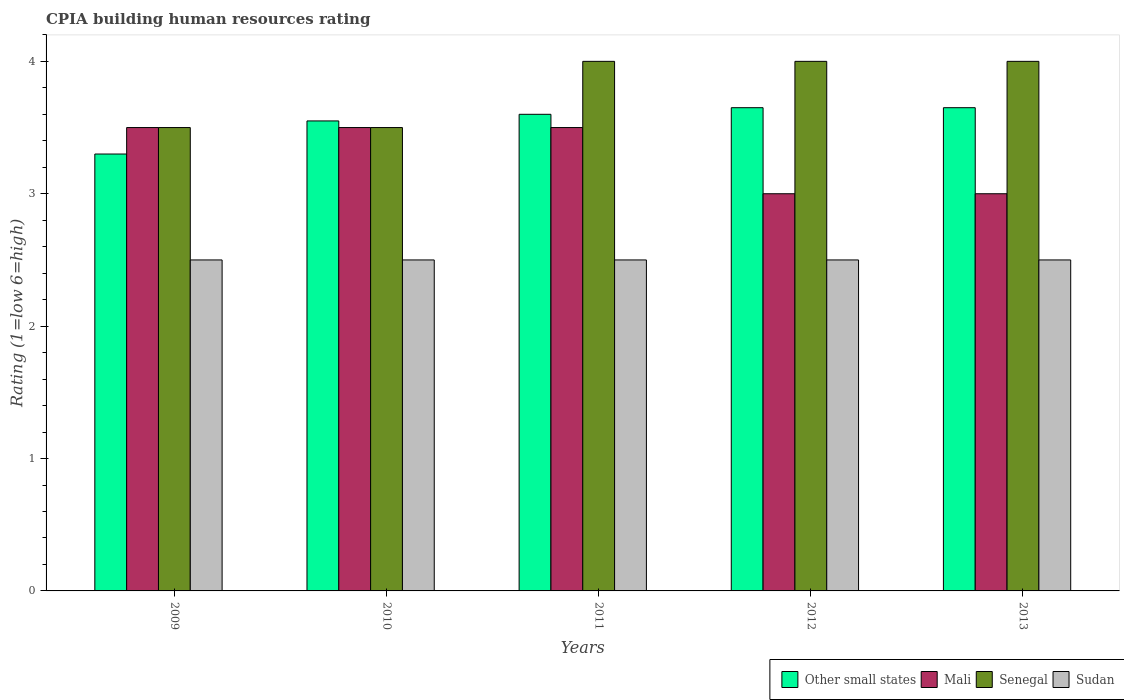Are the number of bars on each tick of the X-axis equal?
Your answer should be very brief. Yes. How many bars are there on the 3rd tick from the right?
Keep it short and to the point. 4. What is the label of the 1st group of bars from the left?
Keep it short and to the point. 2009. In how many cases, is the number of bars for a given year not equal to the number of legend labels?
Provide a succinct answer. 0. Across all years, what is the minimum CPIA rating in Senegal?
Offer a very short reply. 3.5. In which year was the CPIA rating in Sudan maximum?
Provide a short and direct response. 2009. What is the total CPIA rating in Other small states in the graph?
Your answer should be very brief. 17.75. What is the difference between the CPIA rating in Other small states in 2010 and that in 2013?
Ensure brevity in your answer.  -0.1. What is the difference between the CPIA rating in Senegal in 2012 and the CPIA rating in Other small states in 2013?
Ensure brevity in your answer.  0.35. In how many years, is the CPIA rating in Senegal greater than 1.8?
Provide a short and direct response. 5. What is the ratio of the CPIA rating in Other small states in 2011 to that in 2013?
Provide a short and direct response. 0.99. Is the difference between the CPIA rating in Sudan in 2009 and 2013 greater than the difference between the CPIA rating in Mali in 2009 and 2013?
Your answer should be very brief. No. In how many years, is the CPIA rating in Senegal greater than the average CPIA rating in Senegal taken over all years?
Keep it short and to the point. 3. Is it the case that in every year, the sum of the CPIA rating in Sudan and CPIA rating in Other small states is greater than the sum of CPIA rating in Mali and CPIA rating in Senegal?
Keep it short and to the point. No. What does the 1st bar from the left in 2013 represents?
Make the answer very short. Other small states. What does the 4th bar from the right in 2009 represents?
Provide a succinct answer. Other small states. How many bars are there?
Your response must be concise. 20. How many years are there in the graph?
Provide a short and direct response. 5. Are the values on the major ticks of Y-axis written in scientific E-notation?
Give a very brief answer. No. Does the graph contain any zero values?
Make the answer very short. No. Does the graph contain grids?
Keep it short and to the point. No. Where does the legend appear in the graph?
Your response must be concise. Bottom right. What is the title of the graph?
Keep it short and to the point. CPIA building human resources rating. Does "Switzerland" appear as one of the legend labels in the graph?
Keep it short and to the point. No. What is the label or title of the X-axis?
Make the answer very short. Years. What is the Rating (1=low 6=high) of Other small states in 2009?
Offer a very short reply. 3.3. What is the Rating (1=low 6=high) of Mali in 2009?
Offer a very short reply. 3.5. What is the Rating (1=low 6=high) in Other small states in 2010?
Your answer should be very brief. 3.55. What is the Rating (1=low 6=high) of Mali in 2010?
Make the answer very short. 3.5. What is the Rating (1=low 6=high) in Senegal in 2010?
Give a very brief answer. 3.5. What is the Rating (1=low 6=high) of Senegal in 2011?
Provide a succinct answer. 4. What is the Rating (1=low 6=high) in Sudan in 2011?
Your response must be concise. 2.5. What is the Rating (1=low 6=high) in Other small states in 2012?
Your response must be concise. 3.65. What is the Rating (1=low 6=high) in Other small states in 2013?
Make the answer very short. 3.65. Across all years, what is the maximum Rating (1=low 6=high) in Other small states?
Offer a very short reply. 3.65. Across all years, what is the maximum Rating (1=low 6=high) in Mali?
Offer a very short reply. 3.5. Across all years, what is the maximum Rating (1=low 6=high) in Senegal?
Offer a terse response. 4. Across all years, what is the maximum Rating (1=low 6=high) of Sudan?
Make the answer very short. 2.5. Across all years, what is the minimum Rating (1=low 6=high) of Sudan?
Provide a short and direct response. 2.5. What is the total Rating (1=low 6=high) of Other small states in the graph?
Your answer should be compact. 17.75. What is the total Rating (1=low 6=high) of Mali in the graph?
Ensure brevity in your answer.  16.5. What is the total Rating (1=low 6=high) of Senegal in the graph?
Make the answer very short. 19. What is the total Rating (1=low 6=high) of Sudan in the graph?
Your response must be concise. 12.5. What is the difference between the Rating (1=low 6=high) in Other small states in 2009 and that in 2010?
Your answer should be compact. -0.25. What is the difference between the Rating (1=low 6=high) in Other small states in 2009 and that in 2011?
Make the answer very short. -0.3. What is the difference between the Rating (1=low 6=high) in Other small states in 2009 and that in 2012?
Make the answer very short. -0.35. What is the difference between the Rating (1=low 6=high) of Mali in 2009 and that in 2012?
Provide a short and direct response. 0.5. What is the difference between the Rating (1=low 6=high) of Sudan in 2009 and that in 2012?
Give a very brief answer. 0. What is the difference between the Rating (1=low 6=high) of Other small states in 2009 and that in 2013?
Offer a very short reply. -0.35. What is the difference between the Rating (1=low 6=high) of Sudan in 2009 and that in 2013?
Your answer should be compact. 0. What is the difference between the Rating (1=low 6=high) in Other small states in 2010 and that in 2011?
Give a very brief answer. -0.05. What is the difference between the Rating (1=low 6=high) in Senegal in 2010 and that in 2011?
Your answer should be compact. -0.5. What is the difference between the Rating (1=low 6=high) of Other small states in 2010 and that in 2013?
Offer a terse response. -0.1. What is the difference between the Rating (1=low 6=high) in Mali in 2010 and that in 2013?
Keep it short and to the point. 0.5. What is the difference between the Rating (1=low 6=high) in Other small states in 2011 and that in 2012?
Provide a short and direct response. -0.05. What is the difference between the Rating (1=low 6=high) in Mali in 2011 and that in 2013?
Ensure brevity in your answer.  0.5. What is the difference between the Rating (1=low 6=high) of Senegal in 2011 and that in 2013?
Make the answer very short. 0. What is the difference between the Rating (1=low 6=high) of Other small states in 2012 and that in 2013?
Provide a succinct answer. 0. What is the difference between the Rating (1=low 6=high) of Mali in 2012 and that in 2013?
Offer a very short reply. 0. What is the difference between the Rating (1=low 6=high) in Senegal in 2012 and that in 2013?
Keep it short and to the point. 0. What is the difference between the Rating (1=low 6=high) in Other small states in 2009 and the Rating (1=low 6=high) in Senegal in 2010?
Keep it short and to the point. -0.2. What is the difference between the Rating (1=low 6=high) of Mali in 2009 and the Rating (1=low 6=high) of Senegal in 2010?
Offer a very short reply. 0. What is the difference between the Rating (1=low 6=high) in Senegal in 2009 and the Rating (1=low 6=high) in Sudan in 2010?
Your answer should be very brief. 1. What is the difference between the Rating (1=low 6=high) in Other small states in 2009 and the Rating (1=low 6=high) in Mali in 2011?
Offer a very short reply. -0.2. What is the difference between the Rating (1=low 6=high) of Other small states in 2009 and the Rating (1=low 6=high) of Sudan in 2011?
Make the answer very short. 0.8. What is the difference between the Rating (1=low 6=high) of Mali in 2009 and the Rating (1=low 6=high) of Senegal in 2011?
Your answer should be very brief. -0.5. What is the difference between the Rating (1=low 6=high) of Other small states in 2009 and the Rating (1=low 6=high) of Senegal in 2012?
Provide a succinct answer. -0.7. What is the difference between the Rating (1=low 6=high) in Mali in 2009 and the Rating (1=low 6=high) in Senegal in 2012?
Provide a short and direct response. -0.5. What is the difference between the Rating (1=low 6=high) in Senegal in 2009 and the Rating (1=low 6=high) in Sudan in 2012?
Provide a succinct answer. 1. What is the difference between the Rating (1=low 6=high) of Mali in 2009 and the Rating (1=low 6=high) of Senegal in 2013?
Give a very brief answer. -0.5. What is the difference between the Rating (1=low 6=high) of Other small states in 2010 and the Rating (1=low 6=high) of Senegal in 2011?
Ensure brevity in your answer.  -0.45. What is the difference between the Rating (1=low 6=high) in Other small states in 2010 and the Rating (1=low 6=high) in Sudan in 2011?
Make the answer very short. 1.05. What is the difference between the Rating (1=low 6=high) of Mali in 2010 and the Rating (1=low 6=high) of Senegal in 2011?
Offer a terse response. -0.5. What is the difference between the Rating (1=low 6=high) in Mali in 2010 and the Rating (1=low 6=high) in Sudan in 2011?
Ensure brevity in your answer.  1. What is the difference between the Rating (1=low 6=high) in Senegal in 2010 and the Rating (1=low 6=high) in Sudan in 2011?
Offer a very short reply. 1. What is the difference between the Rating (1=low 6=high) of Other small states in 2010 and the Rating (1=low 6=high) of Mali in 2012?
Keep it short and to the point. 0.55. What is the difference between the Rating (1=low 6=high) of Other small states in 2010 and the Rating (1=low 6=high) of Senegal in 2012?
Ensure brevity in your answer.  -0.45. What is the difference between the Rating (1=low 6=high) in Mali in 2010 and the Rating (1=low 6=high) in Senegal in 2012?
Ensure brevity in your answer.  -0.5. What is the difference between the Rating (1=low 6=high) of Other small states in 2010 and the Rating (1=low 6=high) of Mali in 2013?
Your response must be concise. 0.55. What is the difference between the Rating (1=low 6=high) in Other small states in 2010 and the Rating (1=low 6=high) in Senegal in 2013?
Offer a terse response. -0.45. What is the difference between the Rating (1=low 6=high) in Other small states in 2010 and the Rating (1=low 6=high) in Sudan in 2013?
Provide a short and direct response. 1.05. What is the difference between the Rating (1=low 6=high) in Mali in 2010 and the Rating (1=low 6=high) in Senegal in 2013?
Give a very brief answer. -0.5. What is the difference between the Rating (1=low 6=high) in Mali in 2010 and the Rating (1=low 6=high) in Sudan in 2013?
Offer a very short reply. 1. What is the difference between the Rating (1=low 6=high) in Other small states in 2011 and the Rating (1=low 6=high) in Mali in 2012?
Give a very brief answer. 0.6. What is the difference between the Rating (1=low 6=high) in Other small states in 2011 and the Rating (1=low 6=high) in Senegal in 2012?
Give a very brief answer. -0.4. What is the difference between the Rating (1=low 6=high) in Other small states in 2011 and the Rating (1=low 6=high) in Sudan in 2012?
Ensure brevity in your answer.  1.1. What is the difference between the Rating (1=low 6=high) in Mali in 2011 and the Rating (1=low 6=high) in Sudan in 2012?
Offer a terse response. 1. What is the difference between the Rating (1=low 6=high) of Senegal in 2011 and the Rating (1=low 6=high) of Sudan in 2012?
Offer a very short reply. 1.5. What is the difference between the Rating (1=low 6=high) of Mali in 2011 and the Rating (1=low 6=high) of Senegal in 2013?
Give a very brief answer. -0.5. What is the difference between the Rating (1=low 6=high) in Mali in 2011 and the Rating (1=low 6=high) in Sudan in 2013?
Provide a succinct answer. 1. What is the difference between the Rating (1=low 6=high) of Senegal in 2011 and the Rating (1=low 6=high) of Sudan in 2013?
Offer a very short reply. 1.5. What is the difference between the Rating (1=low 6=high) in Other small states in 2012 and the Rating (1=low 6=high) in Mali in 2013?
Give a very brief answer. 0.65. What is the difference between the Rating (1=low 6=high) in Other small states in 2012 and the Rating (1=low 6=high) in Senegal in 2013?
Give a very brief answer. -0.35. What is the difference between the Rating (1=low 6=high) of Other small states in 2012 and the Rating (1=low 6=high) of Sudan in 2013?
Make the answer very short. 1.15. What is the difference between the Rating (1=low 6=high) in Mali in 2012 and the Rating (1=low 6=high) in Senegal in 2013?
Make the answer very short. -1. What is the difference between the Rating (1=low 6=high) of Mali in 2012 and the Rating (1=low 6=high) of Sudan in 2013?
Provide a succinct answer. 0.5. What is the average Rating (1=low 6=high) in Other small states per year?
Offer a terse response. 3.55. What is the average Rating (1=low 6=high) of Mali per year?
Your answer should be very brief. 3.3. In the year 2009, what is the difference between the Rating (1=low 6=high) in Other small states and Rating (1=low 6=high) in Sudan?
Your answer should be very brief. 0.8. In the year 2010, what is the difference between the Rating (1=low 6=high) of Other small states and Rating (1=low 6=high) of Sudan?
Your answer should be very brief. 1.05. In the year 2011, what is the difference between the Rating (1=low 6=high) of Other small states and Rating (1=low 6=high) of Senegal?
Make the answer very short. -0.4. In the year 2011, what is the difference between the Rating (1=low 6=high) of Mali and Rating (1=low 6=high) of Sudan?
Ensure brevity in your answer.  1. In the year 2011, what is the difference between the Rating (1=low 6=high) of Senegal and Rating (1=low 6=high) of Sudan?
Your answer should be very brief. 1.5. In the year 2012, what is the difference between the Rating (1=low 6=high) in Other small states and Rating (1=low 6=high) in Mali?
Provide a succinct answer. 0.65. In the year 2012, what is the difference between the Rating (1=low 6=high) of Other small states and Rating (1=low 6=high) of Senegal?
Your response must be concise. -0.35. In the year 2012, what is the difference between the Rating (1=low 6=high) of Other small states and Rating (1=low 6=high) of Sudan?
Provide a short and direct response. 1.15. In the year 2012, what is the difference between the Rating (1=low 6=high) in Mali and Rating (1=low 6=high) in Senegal?
Keep it short and to the point. -1. In the year 2012, what is the difference between the Rating (1=low 6=high) of Mali and Rating (1=low 6=high) of Sudan?
Provide a short and direct response. 0.5. In the year 2013, what is the difference between the Rating (1=low 6=high) of Other small states and Rating (1=low 6=high) of Mali?
Ensure brevity in your answer.  0.65. In the year 2013, what is the difference between the Rating (1=low 6=high) in Other small states and Rating (1=low 6=high) in Senegal?
Your response must be concise. -0.35. In the year 2013, what is the difference between the Rating (1=low 6=high) of Other small states and Rating (1=low 6=high) of Sudan?
Offer a very short reply. 1.15. In the year 2013, what is the difference between the Rating (1=low 6=high) in Mali and Rating (1=low 6=high) in Sudan?
Your response must be concise. 0.5. What is the ratio of the Rating (1=low 6=high) in Other small states in 2009 to that in 2010?
Offer a very short reply. 0.93. What is the ratio of the Rating (1=low 6=high) in Senegal in 2009 to that in 2010?
Provide a succinct answer. 1. What is the ratio of the Rating (1=low 6=high) of Sudan in 2009 to that in 2010?
Ensure brevity in your answer.  1. What is the ratio of the Rating (1=low 6=high) of Mali in 2009 to that in 2011?
Your response must be concise. 1. What is the ratio of the Rating (1=low 6=high) of Senegal in 2009 to that in 2011?
Give a very brief answer. 0.88. What is the ratio of the Rating (1=low 6=high) in Sudan in 2009 to that in 2011?
Offer a terse response. 1. What is the ratio of the Rating (1=low 6=high) of Other small states in 2009 to that in 2012?
Your response must be concise. 0.9. What is the ratio of the Rating (1=low 6=high) of Mali in 2009 to that in 2012?
Your response must be concise. 1.17. What is the ratio of the Rating (1=low 6=high) in Senegal in 2009 to that in 2012?
Your response must be concise. 0.88. What is the ratio of the Rating (1=low 6=high) in Sudan in 2009 to that in 2012?
Offer a very short reply. 1. What is the ratio of the Rating (1=low 6=high) in Other small states in 2009 to that in 2013?
Make the answer very short. 0.9. What is the ratio of the Rating (1=low 6=high) in Mali in 2009 to that in 2013?
Keep it short and to the point. 1.17. What is the ratio of the Rating (1=low 6=high) of Sudan in 2009 to that in 2013?
Your answer should be very brief. 1. What is the ratio of the Rating (1=low 6=high) of Other small states in 2010 to that in 2011?
Provide a short and direct response. 0.99. What is the ratio of the Rating (1=low 6=high) in Senegal in 2010 to that in 2011?
Your response must be concise. 0.88. What is the ratio of the Rating (1=low 6=high) in Other small states in 2010 to that in 2012?
Your answer should be very brief. 0.97. What is the ratio of the Rating (1=low 6=high) of Senegal in 2010 to that in 2012?
Ensure brevity in your answer.  0.88. What is the ratio of the Rating (1=low 6=high) in Sudan in 2010 to that in 2012?
Offer a very short reply. 1. What is the ratio of the Rating (1=low 6=high) in Other small states in 2010 to that in 2013?
Offer a very short reply. 0.97. What is the ratio of the Rating (1=low 6=high) of Other small states in 2011 to that in 2012?
Your answer should be compact. 0.99. What is the ratio of the Rating (1=low 6=high) in Mali in 2011 to that in 2012?
Make the answer very short. 1.17. What is the ratio of the Rating (1=low 6=high) of Other small states in 2011 to that in 2013?
Provide a short and direct response. 0.99. What is the ratio of the Rating (1=low 6=high) in Mali in 2011 to that in 2013?
Make the answer very short. 1.17. What is the ratio of the Rating (1=low 6=high) of Sudan in 2011 to that in 2013?
Your answer should be compact. 1. What is the ratio of the Rating (1=low 6=high) of Other small states in 2012 to that in 2013?
Give a very brief answer. 1. What is the ratio of the Rating (1=low 6=high) of Senegal in 2012 to that in 2013?
Keep it short and to the point. 1. What is the difference between the highest and the second highest Rating (1=low 6=high) in Sudan?
Provide a short and direct response. 0. What is the difference between the highest and the lowest Rating (1=low 6=high) in Other small states?
Provide a short and direct response. 0.35. What is the difference between the highest and the lowest Rating (1=low 6=high) in Mali?
Your answer should be very brief. 0.5. What is the difference between the highest and the lowest Rating (1=low 6=high) of Senegal?
Keep it short and to the point. 0.5. 